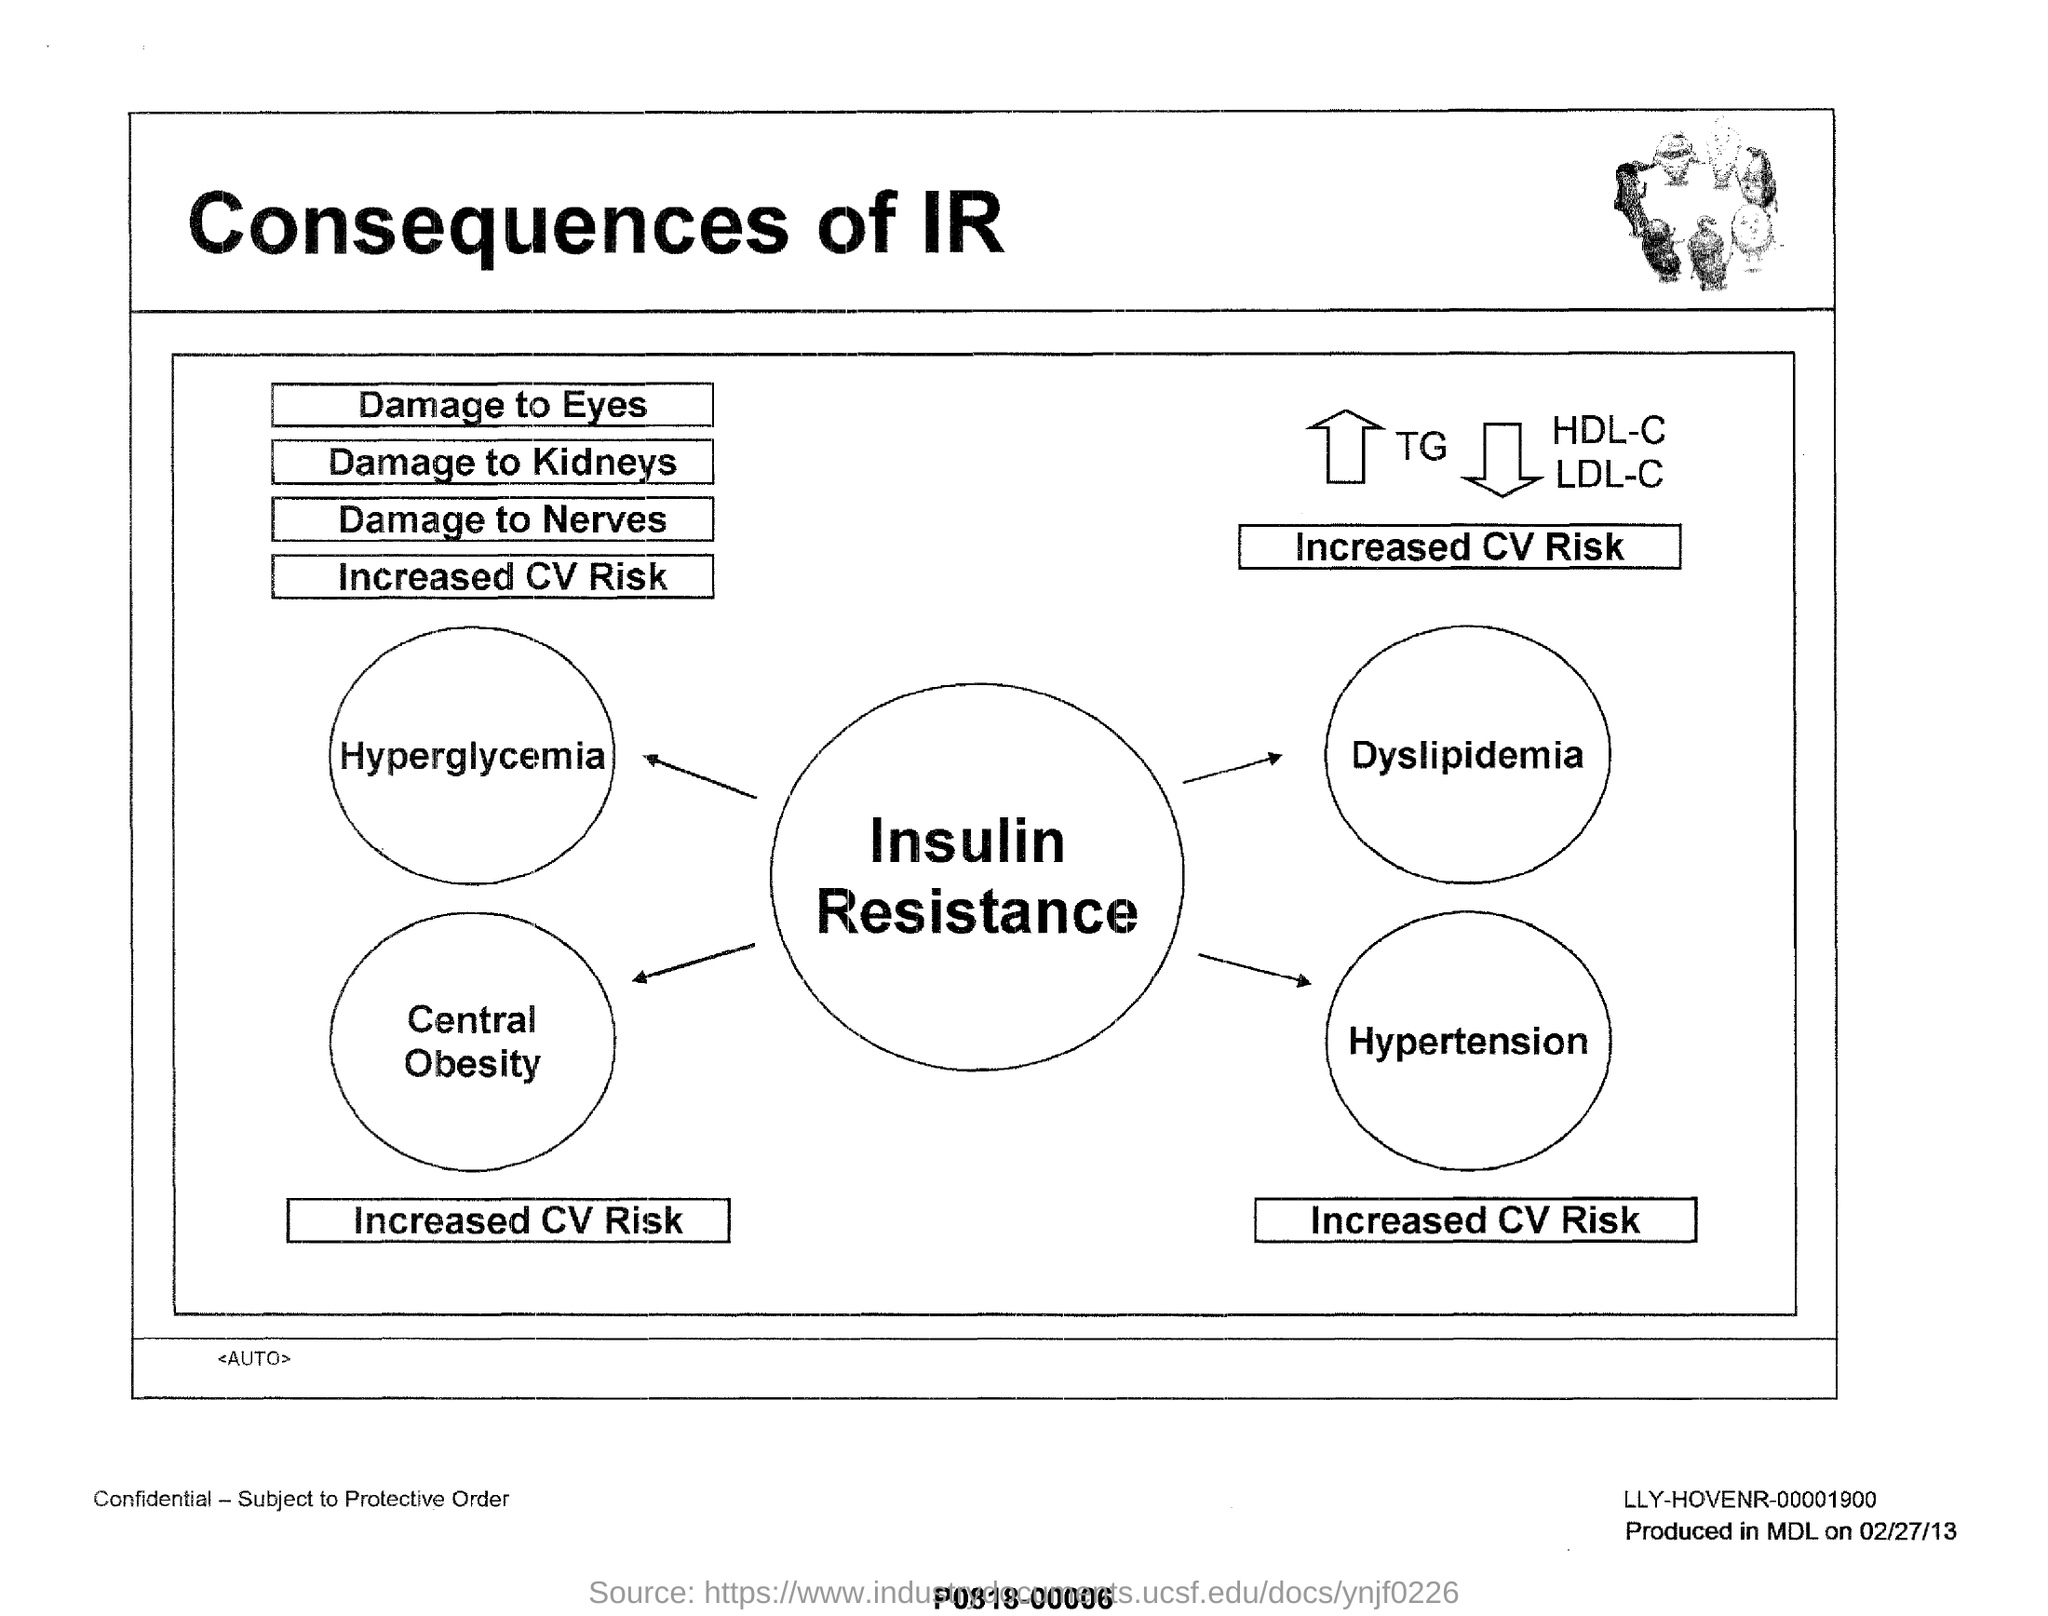What is the title of this document?
Provide a short and direct response. Consequences of IR. 